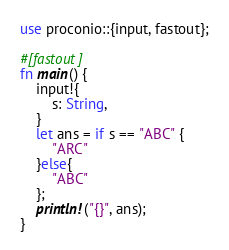Convert code to text. <code><loc_0><loc_0><loc_500><loc_500><_Rust_>use proconio::{input, fastout};

#[fastout]
fn main() {
    input!{
        s: String,
    }
    let ans = if s == "ABC" {
        "ARC"
    }else{
        "ABC"
    };
    println!("{}", ans);
}
</code> 